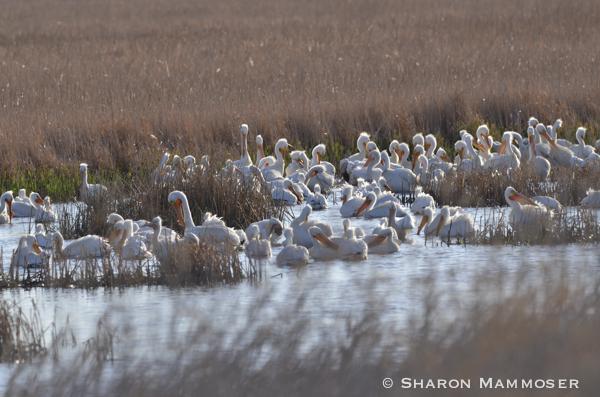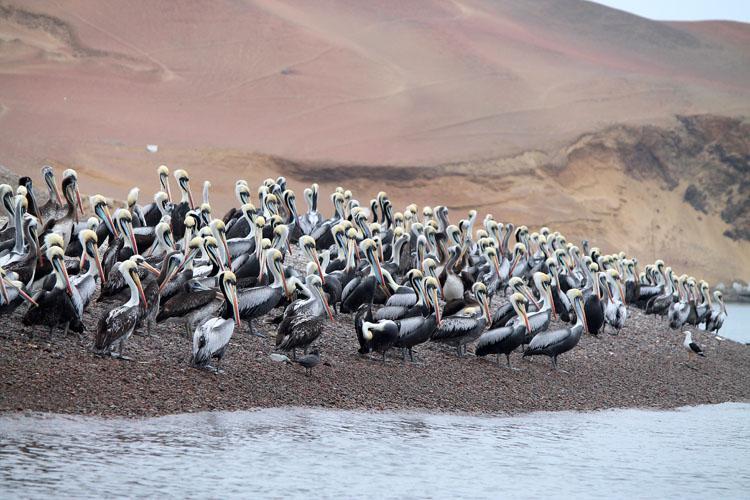The first image is the image on the left, the second image is the image on the right. Analyze the images presented: Is the assertion "Birds are all in a group on an area of dry ground surrounded by water, in one image." valid? Answer yes or no. Yes. 